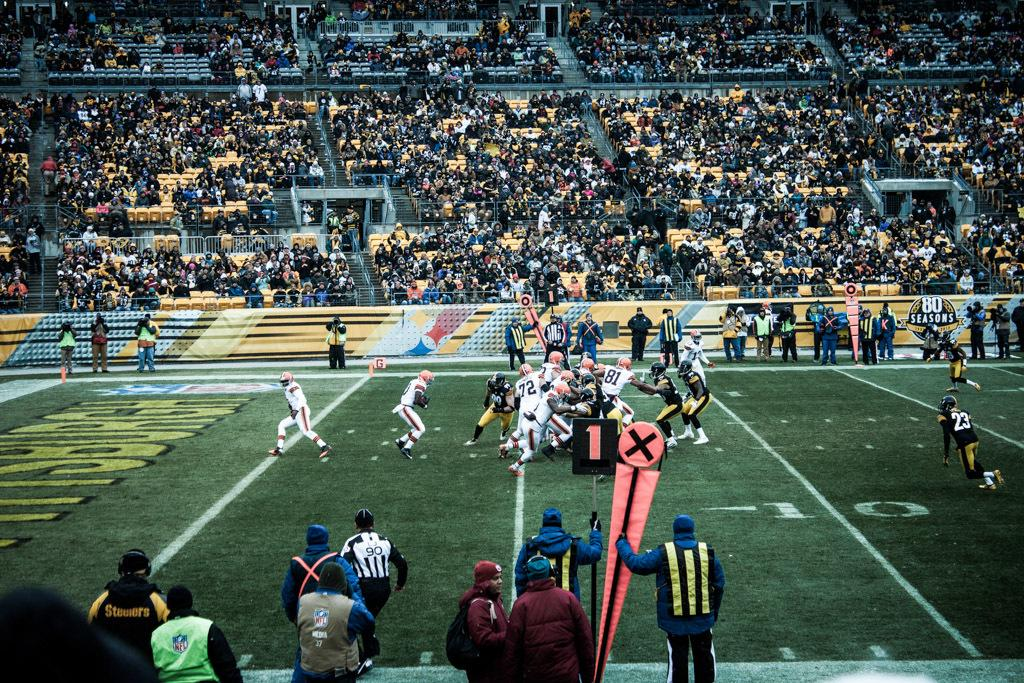<image>
Offer a succinct explanation of the picture presented. A referee in a football game has the number 90 on the back of his shirt. 